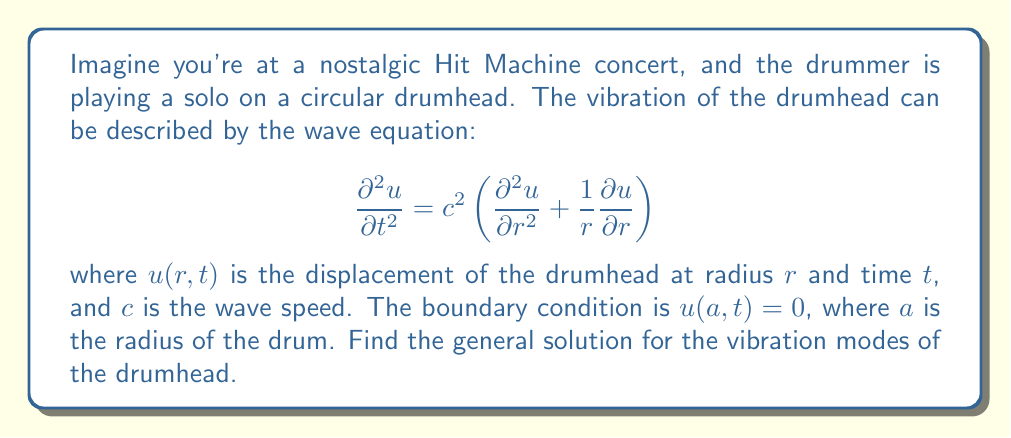Can you solve this math problem? To solve this PDE, we'll use the method of separation of variables:

1) Assume the solution has the form: $u(r,t) = R(r)T(t)$

2) Substituting this into the wave equation:
   $$RT'' = c^2\left(R''T + \frac{1}{r}R'T\right)$$

3) Dividing by $RT$:
   $$\frac{T''}{T} = c^2\left(\frac{R''}{R} + \frac{1}{r}\frac{R'}{R}\right) = -\lambda^2$$
   where $\lambda^2$ is a separation constant.

4) This gives us two ODEs:
   $$T'' + \lambda^2c^2T = 0$$
   $$r^2R'' + rR' + \lambda^2r^2R = 0$$

5) The solution for $T(t)$ is:
   $$T(t) = A\cos(\lambda ct) + B\sin(\lambda ct)$$

6) The equation for $R(r)$ is a Bessel equation of order 0. Its solution is:
   $$R(r) = CJ_0(\lambda r) + DY_0(\lambda r)$$
   where $J_0$ and $Y_0$ are Bessel functions of the first and second kind.

7) Since $Y_0$ is singular at $r=0$, we must have $D=0$ for a physical solution.

8) Applying the boundary condition $u(a,t) = 0$:
   $$CJ_0(\lambda a) = 0$$

9) This means $\lambda a$ must be a zero of $J_0$. Let's denote the $n$-th zero of $J_0$ as $j_{0,n}$. Then:
   $$\lambda_n = \frac{j_{0,n}}{a}$$

10) The general solution is a superposition of all possible modes:
    $$u(r,t) = \sum_{n=1}^{\infty} J_0\left(\frac{j_{0,n}r}{a}\right)[A_n\cos(\lambda_nct) + B_n\sin(\lambda_nct)]$$
Answer: The general solution for the vibration modes of the drumhead is:

$$u(r,t) = \sum_{n=1}^{\infty} J_0\left(\frac{j_{0,n}r}{a}\right)[A_n\cos(\lambda_nct) + B_n\sin(\lambda_nct)]$$

where $j_{0,n}$ is the $n$-th zero of the Bessel function $J_0$, $\lambda_n = \frac{j_{0,n}}{a}$, and $A_n$ and $B_n$ are constants determined by initial conditions. 